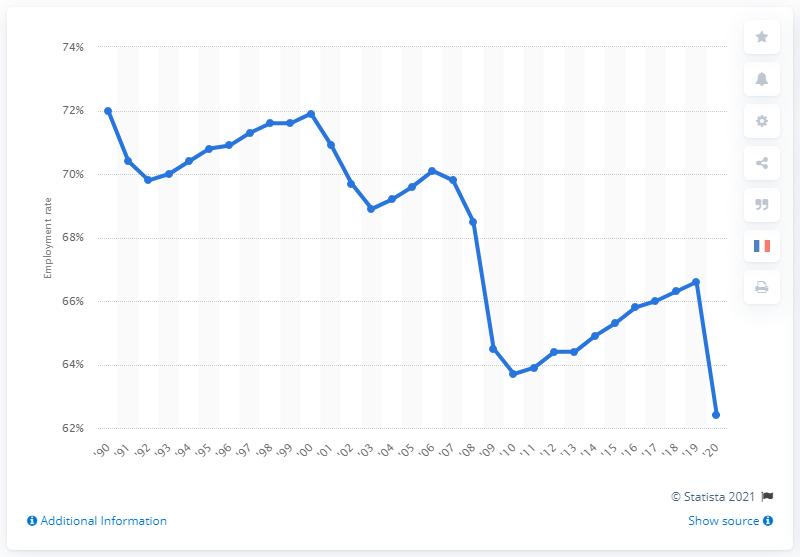Give some essential details in this illustration. In 2020, the employment rate of men in the United States was 62.4%. 